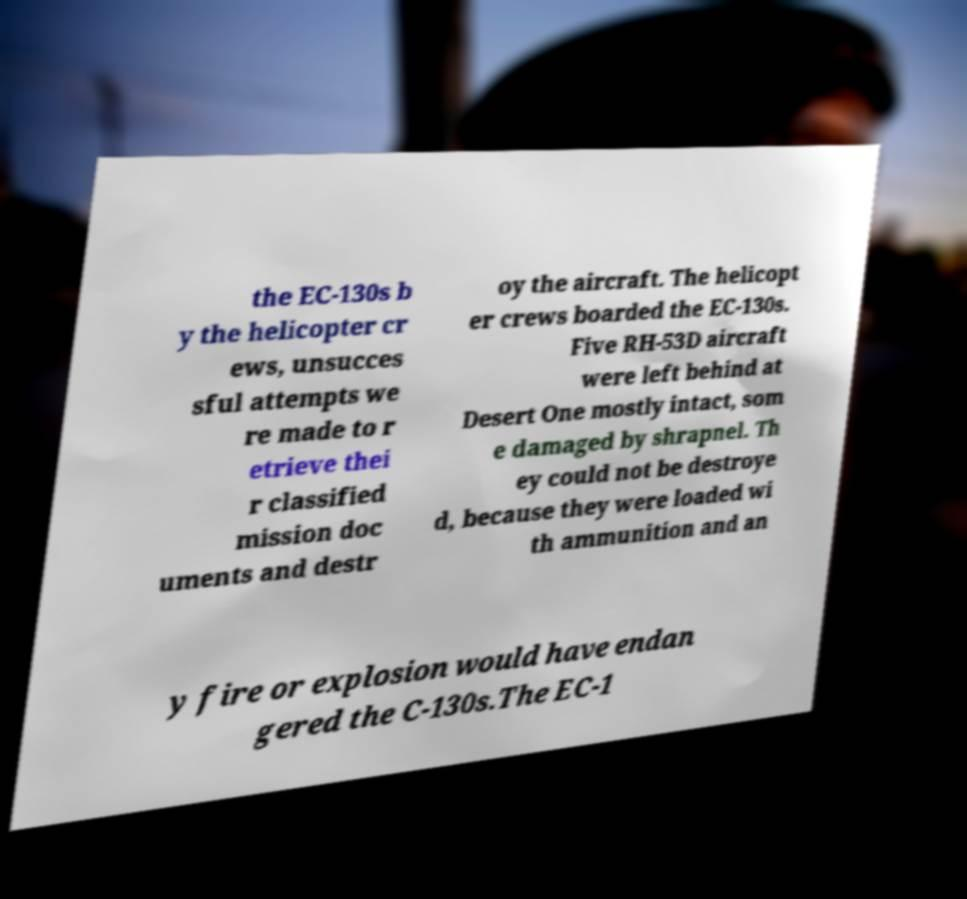Could you assist in decoding the text presented in this image and type it out clearly? the EC-130s b y the helicopter cr ews, unsucces sful attempts we re made to r etrieve thei r classified mission doc uments and destr oy the aircraft. The helicopt er crews boarded the EC-130s. Five RH-53D aircraft were left behind at Desert One mostly intact, som e damaged by shrapnel. Th ey could not be destroye d, because they were loaded wi th ammunition and an y fire or explosion would have endan gered the C-130s.The EC-1 